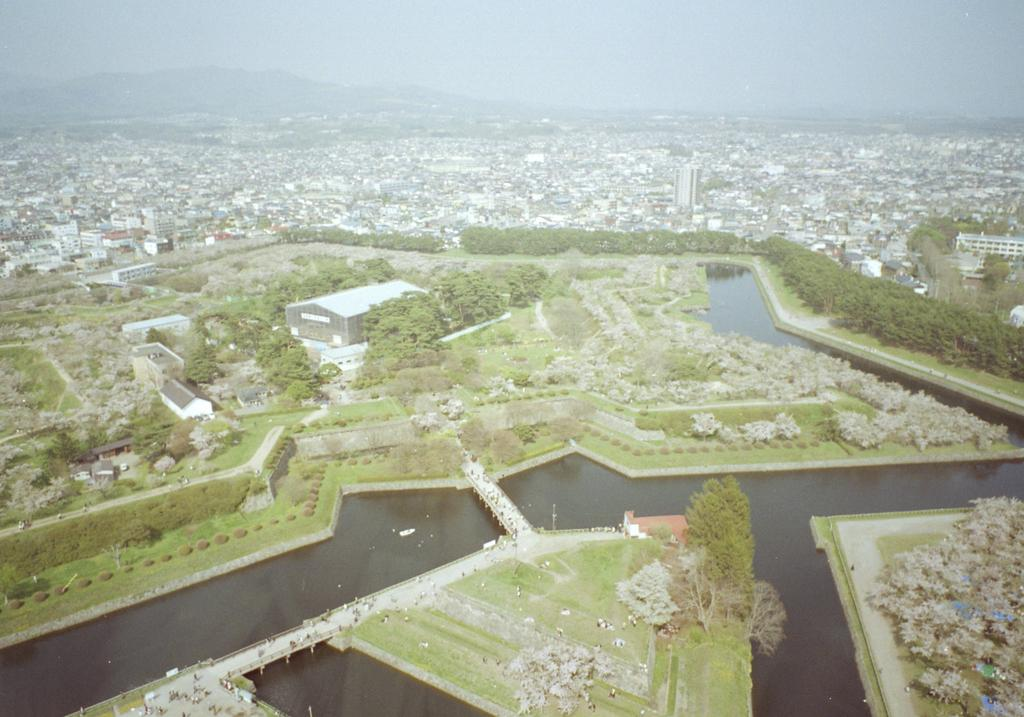What type of structures can be seen in the image? There are buildings in the image. What natural elements are present in the image? There are trees, water, grass, and mountains in the image. Can you describe the people in the image? There are people in the image, but their specific actions or characteristics are not mentioned in the facts. What architectural feature is present in the image? There is a bridge in the image. What part of the natural environment is visible in the background of the image? The sky is visible in the background of the image. What type of store can be seen in the image? There is no store mentioned or visible in the image. What day of the week is it in the image? The day of the week is not mentioned or visible in the image. 